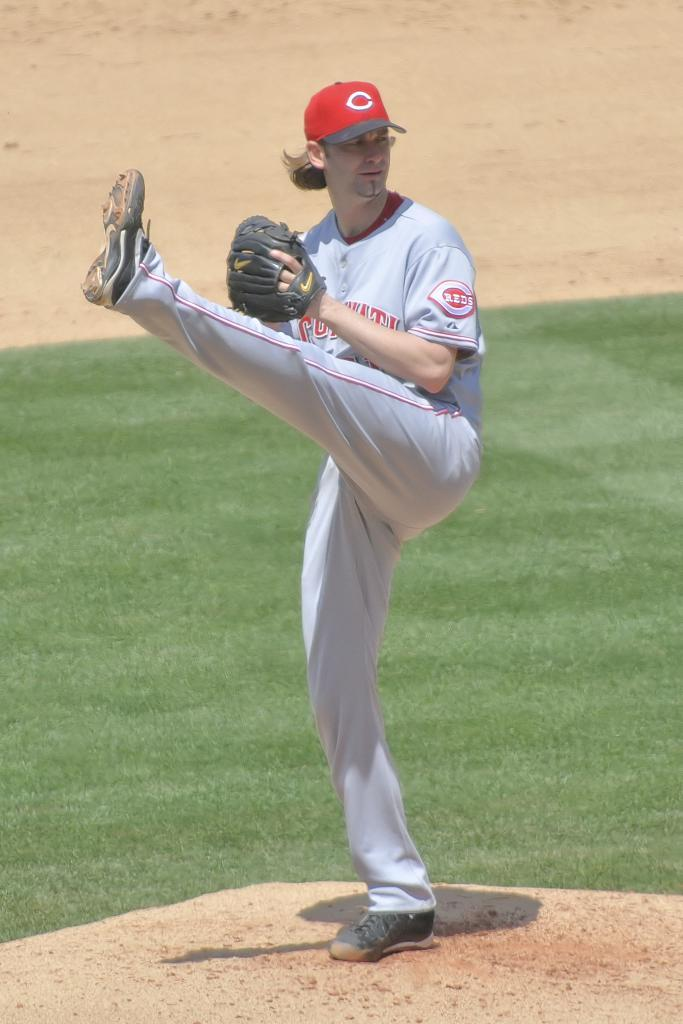Who is present in the image? There is a man in the image. What is the man wearing? The man is wearing sports wear. What is the man doing in the image? The man is standing on one leg. What type of surface can be seen in the image? There is a grass surface and a muddy surface visible in the image. Where is the kitten playing in the office in the image? There is no kitten or office present in the image; it features a man wearing sports wear and standing on one leg on a grass and muddy surface. 